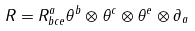<formula> <loc_0><loc_0><loc_500><loc_500>R = R _ { b c e } ^ { a } \theta ^ { b } \otimes \theta ^ { c } \otimes \theta ^ { e } \otimes \partial _ { a }</formula> 